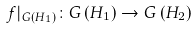<formula> <loc_0><loc_0><loc_500><loc_500>f | _ { G \left ( H _ { 1 } \right ) } \colon G \left ( H _ { 1 } \right ) \rightarrow G \left ( H _ { 2 } \right )</formula> 